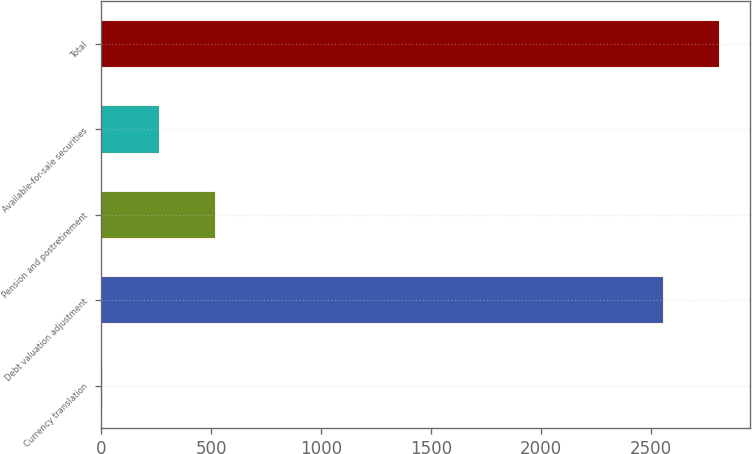<chart> <loc_0><loc_0><loc_500><loc_500><bar_chart><fcel>Currency translation<fcel>Debt valuation adjustment<fcel>Pension and postretirement<fcel>Available-for-sale securities<fcel>Total<nl><fcel>4<fcel>2553<fcel>517.8<fcel>260.9<fcel>2809.9<nl></chart> 